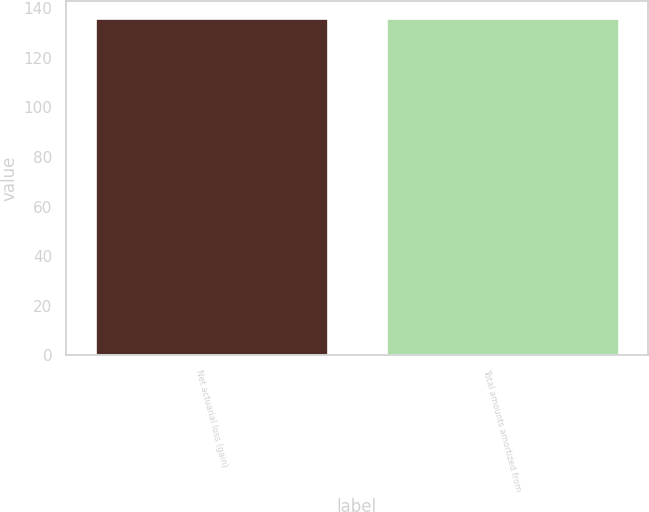Convert chart to OTSL. <chart><loc_0><loc_0><loc_500><loc_500><bar_chart><fcel>Net actuarial loss (gain)<fcel>Total amounts amortized from<nl><fcel>136<fcel>136.1<nl></chart> 